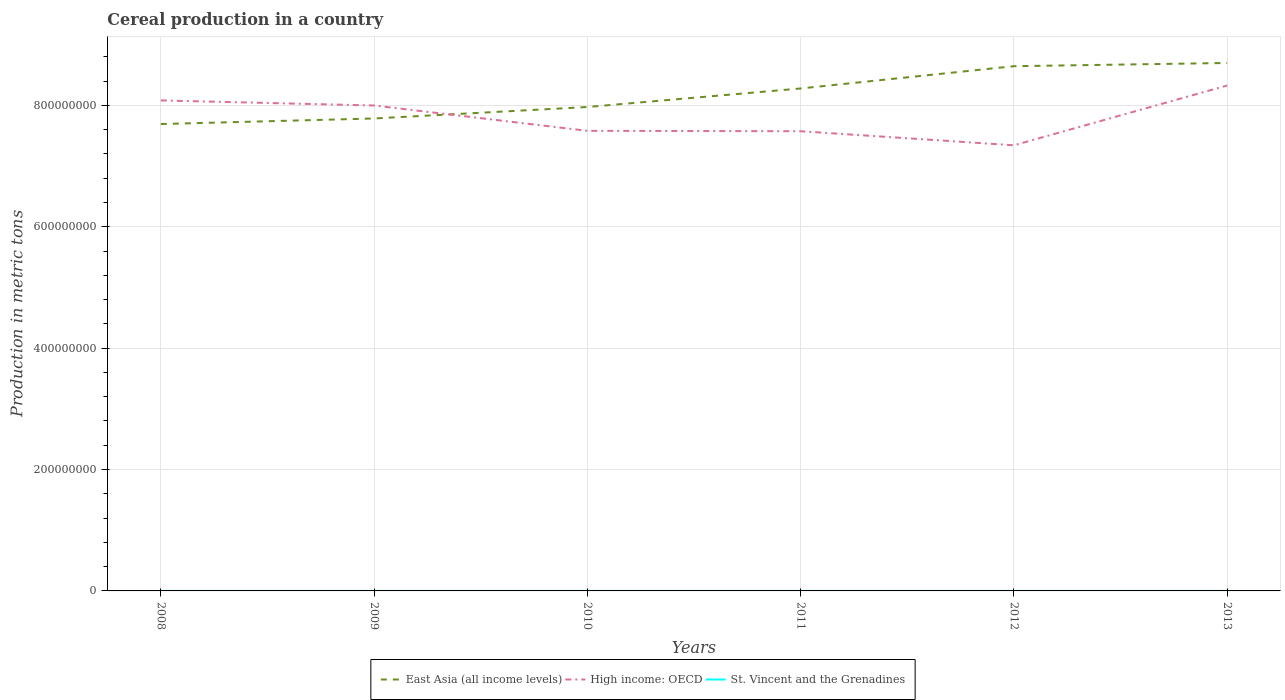Across all years, what is the maximum total cereal production in St. Vincent and the Grenadines?
Provide a succinct answer. 582. In which year was the total cereal production in High income: OECD maximum?
Make the answer very short. 2012. What is the total total cereal production in East Asia (all income levels) in the graph?
Your response must be concise. -9.53e+07. What is the difference between the highest and the second highest total cereal production in High income: OECD?
Ensure brevity in your answer.  9.85e+07. What is the difference between the highest and the lowest total cereal production in St. Vincent and the Grenadines?
Provide a succinct answer. 2. How many years are there in the graph?
Keep it short and to the point. 6. Where does the legend appear in the graph?
Keep it short and to the point. Bottom center. What is the title of the graph?
Provide a succinct answer. Cereal production in a country. What is the label or title of the X-axis?
Offer a very short reply. Years. What is the label or title of the Y-axis?
Your answer should be compact. Production in metric tons. What is the Production in metric tons in East Asia (all income levels) in 2008?
Your answer should be compact. 7.69e+08. What is the Production in metric tons of High income: OECD in 2008?
Make the answer very short. 8.08e+08. What is the Production in metric tons of St. Vincent and the Grenadines in 2008?
Your answer should be very brief. 700. What is the Production in metric tons in East Asia (all income levels) in 2009?
Your answer should be compact. 7.78e+08. What is the Production in metric tons in High income: OECD in 2009?
Ensure brevity in your answer.  8.00e+08. What is the Production in metric tons in St. Vincent and the Grenadines in 2009?
Your response must be concise. 670. What is the Production in metric tons in East Asia (all income levels) in 2010?
Provide a short and direct response. 7.97e+08. What is the Production in metric tons in High income: OECD in 2010?
Provide a succinct answer. 7.58e+08. What is the Production in metric tons in St. Vincent and the Grenadines in 2010?
Keep it short and to the point. 582. What is the Production in metric tons of East Asia (all income levels) in 2011?
Your response must be concise. 8.28e+08. What is the Production in metric tons in High income: OECD in 2011?
Make the answer very short. 7.57e+08. What is the Production in metric tons in St. Vincent and the Grenadines in 2011?
Give a very brief answer. 691. What is the Production in metric tons in East Asia (all income levels) in 2012?
Your answer should be very brief. 8.64e+08. What is the Production in metric tons of High income: OECD in 2012?
Your answer should be compact. 7.34e+08. What is the Production in metric tons in St. Vincent and the Grenadines in 2012?
Give a very brief answer. 854. What is the Production in metric tons in East Asia (all income levels) in 2013?
Provide a short and direct response. 8.70e+08. What is the Production in metric tons in High income: OECD in 2013?
Provide a short and direct response. 8.33e+08. What is the Production in metric tons of St. Vincent and the Grenadines in 2013?
Keep it short and to the point. 870. Across all years, what is the maximum Production in metric tons in East Asia (all income levels)?
Provide a short and direct response. 8.70e+08. Across all years, what is the maximum Production in metric tons of High income: OECD?
Offer a very short reply. 8.33e+08. Across all years, what is the maximum Production in metric tons in St. Vincent and the Grenadines?
Your answer should be very brief. 870. Across all years, what is the minimum Production in metric tons in East Asia (all income levels)?
Offer a terse response. 7.69e+08. Across all years, what is the minimum Production in metric tons of High income: OECD?
Give a very brief answer. 7.34e+08. Across all years, what is the minimum Production in metric tons of St. Vincent and the Grenadines?
Offer a terse response. 582. What is the total Production in metric tons in East Asia (all income levels) in the graph?
Provide a succinct answer. 4.91e+09. What is the total Production in metric tons of High income: OECD in the graph?
Make the answer very short. 4.69e+09. What is the total Production in metric tons in St. Vincent and the Grenadines in the graph?
Offer a very short reply. 4367. What is the difference between the Production in metric tons of East Asia (all income levels) in 2008 and that in 2009?
Your answer should be very brief. -9.17e+06. What is the difference between the Production in metric tons in High income: OECD in 2008 and that in 2009?
Make the answer very short. 8.34e+06. What is the difference between the Production in metric tons in East Asia (all income levels) in 2008 and that in 2010?
Provide a short and direct response. -2.81e+07. What is the difference between the Production in metric tons of High income: OECD in 2008 and that in 2010?
Offer a very short reply. 5.01e+07. What is the difference between the Production in metric tons in St. Vincent and the Grenadines in 2008 and that in 2010?
Provide a short and direct response. 118. What is the difference between the Production in metric tons in East Asia (all income levels) in 2008 and that in 2011?
Offer a very short reply. -5.86e+07. What is the difference between the Production in metric tons in High income: OECD in 2008 and that in 2011?
Give a very brief answer. 5.07e+07. What is the difference between the Production in metric tons of St. Vincent and the Grenadines in 2008 and that in 2011?
Offer a very short reply. 9. What is the difference between the Production in metric tons of East Asia (all income levels) in 2008 and that in 2012?
Offer a very short reply. -9.53e+07. What is the difference between the Production in metric tons of High income: OECD in 2008 and that in 2012?
Make the answer very short. 7.39e+07. What is the difference between the Production in metric tons of St. Vincent and the Grenadines in 2008 and that in 2012?
Give a very brief answer. -154. What is the difference between the Production in metric tons of East Asia (all income levels) in 2008 and that in 2013?
Ensure brevity in your answer.  -1.01e+08. What is the difference between the Production in metric tons of High income: OECD in 2008 and that in 2013?
Your response must be concise. -2.46e+07. What is the difference between the Production in metric tons in St. Vincent and the Grenadines in 2008 and that in 2013?
Offer a terse response. -170. What is the difference between the Production in metric tons in East Asia (all income levels) in 2009 and that in 2010?
Offer a very short reply. -1.89e+07. What is the difference between the Production in metric tons in High income: OECD in 2009 and that in 2010?
Your answer should be very brief. 4.17e+07. What is the difference between the Production in metric tons in St. Vincent and the Grenadines in 2009 and that in 2010?
Provide a succinct answer. 88. What is the difference between the Production in metric tons in East Asia (all income levels) in 2009 and that in 2011?
Your answer should be compact. -4.94e+07. What is the difference between the Production in metric tons in High income: OECD in 2009 and that in 2011?
Give a very brief answer. 4.24e+07. What is the difference between the Production in metric tons in St. Vincent and the Grenadines in 2009 and that in 2011?
Your response must be concise. -21. What is the difference between the Production in metric tons of East Asia (all income levels) in 2009 and that in 2012?
Your response must be concise. -8.61e+07. What is the difference between the Production in metric tons in High income: OECD in 2009 and that in 2012?
Your answer should be compact. 6.56e+07. What is the difference between the Production in metric tons of St. Vincent and the Grenadines in 2009 and that in 2012?
Offer a very short reply. -184. What is the difference between the Production in metric tons in East Asia (all income levels) in 2009 and that in 2013?
Your answer should be very brief. -9.14e+07. What is the difference between the Production in metric tons in High income: OECD in 2009 and that in 2013?
Give a very brief answer. -3.29e+07. What is the difference between the Production in metric tons of St. Vincent and the Grenadines in 2009 and that in 2013?
Provide a short and direct response. -200. What is the difference between the Production in metric tons in East Asia (all income levels) in 2010 and that in 2011?
Your answer should be very brief. -3.06e+07. What is the difference between the Production in metric tons of High income: OECD in 2010 and that in 2011?
Keep it short and to the point. 6.61e+05. What is the difference between the Production in metric tons in St. Vincent and the Grenadines in 2010 and that in 2011?
Your response must be concise. -109. What is the difference between the Production in metric tons of East Asia (all income levels) in 2010 and that in 2012?
Your response must be concise. -6.72e+07. What is the difference between the Production in metric tons in High income: OECD in 2010 and that in 2012?
Offer a terse response. 2.38e+07. What is the difference between the Production in metric tons in St. Vincent and the Grenadines in 2010 and that in 2012?
Provide a succinct answer. -272. What is the difference between the Production in metric tons of East Asia (all income levels) in 2010 and that in 2013?
Your answer should be compact. -7.26e+07. What is the difference between the Production in metric tons in High income: OECD in 2010 and that in 2013?
Offer a terse response. -7.47e+07. What is the difference between the Production in metric tons of St. Vincent and the Grenadines in 2010 and that in 2013?
Provide a short and direct response. -288. What is the difference between the Production in metric tons in East Asia (all income levels) in 2011 and that in 2012?
Provide a short and direct response. -3.67e+07. What is the difference between the Production in metric tons of High income: OECD in 2011 and that in 2012?
Offer a very short reply. 2.32e+07. What is the difference between the Production in metric tons of St. Vincent and the Grenadines in 2011 and that in 2012?
Make the answer very short. -163. What is the difference between the Production in metric tons in East Asia (all income levels) in 2011 and that in 2013?
Your answer should be very brief. -4.20e+07. What is the difference between the Production in metric tons in High income: OECD in 2011 and that in 2013?
Give a very brief answer. -7.53e+07. What is the difference between the Production in metric tons in St. Vincent and the Grenadines in 2011 and that in 2013?
Provide a short and direct response. -179. What is the difference between the Production in metric tons of East Asia (all income levels) in 2012 and that in 2013?
Provide a succinct answer. -5.31e+06. What is the difference between the Production in metric tons of High income: OECD in 2012 and that in 2013?
Your answer should be very brief. -9.85e+07. What is the difference between the Production in metric tons of East Asia (all income levels) in 2008 and the Production in metric tons of High income: OECD in 2009?
Provide a succinct answer. -3.06e+07. What is the difference between the Production in metric tons in East Asia (all income levels) in 2008 and the Production in metric tons in St. Vincent and the Grenadines in 2009?
Make the answer very short. 7.69e+08. What is the difference between the Production in metric tons in High income: OECD in 2008 and the Production in metric tons in St. Vincent and the Grenadines in 2009?
Offer a very short reply. 8.08e+08. What is the difference between the Production in metric tons of East Asia (all income levels) in 2008 and the Production in metric tons of High income: OECD in 2010?
Your answer should be compact. 1.12e+07. What is the difference between the Production in metric tons of East Asia (all income levels) in 2008 and the Production in metric tons of St. Vincent and the Grenadines in 2010?
Your answer should be compact. 7.69e+08. What is the difference between the Production in metric tons of High income: OECD in 2008 and the Production in metric tons of St. Vincent and the Grenadines in 2010?
Keep it short and to the point. 8.08e+08. What is the difference between the Production in metric tons of East Asia (all income levels) in 2008 and the Production in metric tons of High income: OECD in 2011?
Offer a very short reply. 1.18e+07. What is the difference between the Production in metric tons of East Asia (all income levels) in 2008 and the Production in metric tons of St. Vincent and the Grenadines in 2011?
Keep it short and to the point. 7.69e+08. What is the difference between the Production in metric tons of High income: OECD in 2008 and the Production in metric tons of St. Vincent and the Grenadines in 2011?
Your answer should be very brief. 8.08e+08. What is the difference between the Production in metric tons of East Asia (all income levels) in 2008 and the Production in metric tons of High income: OECD in 2012?
Provide a succinct answer. 3.50e+07. What is the difference between the Production in metric tons in East Asia (all income levels) in 2008 and the Production in metric tons in St. Vincent and the Grenadines in 2012?
Your response must be concise. 7.69e+08. What is the difference between the Production in metric tons in High income: OECD in 2008 and the Production in metric tons in St. Vincent and the Grenadines in 2012?
Offer a terse response. 8.08e+08. What is the difference between the Production in metric tons of East Asia (all income levels) in 2008 and the Production in metric tons of High income: OECD in 2013?
Give a very brief answer. -6.35e+07. What is the difference between the Production in metric tons in East Asia (all income levels) in 2008 and the Production in metric tons in St. Vincent and the Grenadines in 2013?
Provide a short and direct response. 7.69e+08. What is the difference between the Production in metric tons of High income: OECD in 2008 and the Production in metric tons of St. Vincent and the Grenadines in 2013?
Your response must be concise. 8.08e+08. What is the difference between the Production in metric tons in East Asia (all income levels) in 2009 and the Production in metric tons in High income: OECD in 2010?
Keep it short and to the point. 2.04e+07. What is the difference between the Production in metric tons in East Asia (all income levels) in 2009 and the Production in metric tons in St. Vincent and the Grenadines in 2010?
Offer a terse response. 7.78e+08. What is the difference between the Production in metric tons of High income: OECD in 2009 and the Production in metric tons of St. Vincent and the Grenadines in 2010?
Make the answer very short. 8.00e+08. What is the difference between the Production in metric tons of East Asia (all income levels) in 2009 and the Production in metric tons of High income: OECD in 2011?
Your answer should be very brief. 2.10e+07. What is the difference between the Production in metric tons of East Asia (all income levels) in 2009 and the Production in metric tons of St. Vincent and the Grenadines in 2011?
Make the answer very short. 7.78e+08. What is the difference between the Production in metric tons in High income: OECD in 2009 and the Production in metric tons in St. Vincent and the Grenadines in 2011?
Provide a succinct answer. 8.00e+08. What is the difference between the Production in metric tons in East Asia (all income levels) in 2009 and the Production in metric tons in High income: OECD in 2012?
Provide a succinct answer. 4.42e+07. What is the difference between the Production in metric tons of East Asia (all income levels) in 2009 and the Production in metric tons of St. Vincent and the Grenadines in 2012?
Give a very brief answer. 7.78e+08. What is the difference between the Production in metric tons of High income: OECD in 2009 and the Production in metric tons of St. Vincent and the Grenadines in 2012?
Offer a terse response. 8.00e+08. What is the difference between the Production in metric tons in East Asia (all income levels) in 2009 and the Production in metric tons in High income: OECD in 2013?
Keep it short and to the point. -5.43e+07. What is the difference between the Production in metric tons of East Asia (all income levels) in 2009 and the Production in metric tons of St. Vincent and the Grenadines in 2013?
Make the answer very short. 7.78e+08. What is the difference between the Production in metric tons of High income: OECD in 2009 and the Production in metric tons of St. Vincent and the Grenadines in 2013?
Your answer should be very brief. 8.00e+08. What is the difference between the Production in metric tons of East Asia (all income levels) in 2010 and the Production in metric tons of High income: OECD in 2011?
Your response must be concise. 3.99e+07. What is the difference between the Production in metric tons of East Asia (all income levels) in 2010 and the Production in metric tons of St. Vincent and the Grenadines in 2011?
Your response must be concise. 7.97e+08. What is the difference between the Production in metric tons of High income: OECD in 2010 and the Production in metric tons of St. Vincent and the Grenadines in 2011?
Offer a terse response. 7.58e+08. What is the difference between the Production in metric tons in East Asia (all income levels) in 2010 and the Production in metric tons in High income: OECD in 2012?
Provide a short and direct response. 6.30e+07. What is the difference between the Production in metric tons of East Asia (all income levels) in 2010 and the Production in metric tons of St. Vincent and the Grenadines in 2012?
Ensure brevity in your answer.  7.97e+08. What is the difference between the Production in metric tons in High income: OECD in 2010 and the Production in metric tons in St. Vincent and the Grenadines in 2012?
Ensure brevity in your answer.  7.58e+08. What is the difference between the Production in metric tons of East Asia (all income levels) in 2010 and the Production in metric tons of High income: OECD in 2013?
Give a very brief answer. -3.54e+07. What is the difference between the Production in metric tons in East Asia (all income levels) in 2010 and the Production in metric tons in St. Vincent and the Grenadines in 2013?
Your answer should be compact. 7.97e+08. What is the difference between the Production in metric tons in High income: OECD in 2010 and the Production in metric tons in St. Vincent and the Grenadines in 2013?
Ensure brevity in your answer.  7.58e+08. What is the difference between the Production in metric tons of East Asia (all income levels) in 2011 and the Production in metric tons of High income: OECD in 2012?
Ensure brevity in your answer.  9.36e+07. What is the difference between the Production in metric tons of East Asia (all income levels) in 2011 and the Production in metric tons of St. Vincent and the Grenadines in 2012?
Offer a terse response. 8.28e+08. What is the difference between the Production in metric tons of High income: OECD in 2011 and the Production in metric tons of St. Vincent and the Grenadines in 2012?
Offer a very short reply. 7.57e+08. What is the difference between the Production in metric tons of East Asia (all income levels) in 2011 and the Production in metric tons of High income: OECD in 2013?
Provide a succinct answer. -4.87e+06. What is the difference between the Production in metric tons in East Asia (all income levels) in 2011 and the Production in metric tons in St. Vincent and the Grenadines in 2013?
Your answer should be compact. 8.28e+08. What is the difference between the Production in metric tons of High income: OECD in 2011 and the Production in metric tons of St. Vincent and the Grenadines in 2013?
Provide a short and direct response. 7.57e+08. What is the difference between the Production in metric tons in East Asia (all income levels) in 2012 and the Production in metric tons in High income: OECD in 2013?
Your answer should be compact. 3.18e+07. What is the difference between the Production in metric tons in East Asia (all income levels) in 2012 and the Production in metric tons in St. Vincent and the Grenadines in 2013?
Ensure brevity in your answer.  8.64e+08. What is the difference between the Production in metric tons in High income: OECD in 2012 and the Production in metric tons in St. Vincent and the Grenadines in 2013?
Give a very brief answer. 7.34e+08. What is the average Production in metric tons of East Asia (all income levels) per year?
Keep it short and to the point. 8.18e+08. What is the average Production in metric tons of High income: OECD per year?
Offer a very short reply. 7.82e+08. What is the average Production in metric tons in St. Vincent and the Grenadines per year?
Ensure brevity in your answer.  727.83. In the year 2008, what is the difference between the Production in metric tons in East Asia (all income levels) and Production in metric tons in High income: OECD?
Offer a very short reply. -3.89e+07. In the year 2008, what is the difference between the Production in metric tons in East Asia (all income levels) and Production in metric tons in St. Vincent and the Grenadines?
Keep it short and to the point. 7.69e+08. In the year 2008, what is the difference between the Production in metric tons in High income: OECD and Production in metric tons in St. Vincent and the Grenadines?
Make the answer very short. 8.08e+08. In the year 2009, what is the difference between the Production in metric tons in East Asia (all income levels) and Production in metric tons in High income: OECD?
Provide a succinct answer. -2.14e+07. In the year 2009, what is the difference between the Production in metric tons in East Asia (all income levels) and Production in metric tons in St. Vincent and the Grenadines?
Make the answer very short. 7.78e+08. In the year 2009, what is the difference between the Production in metric tons of High income: OECD and Production in metric tons of St. Vincent and the Grenadines?
Keep it short and to the point. 8.00e+08. In the year 2010, what is the difference between the Production in metric tons in East Asia (all income levels) and Production in metric tons in High income: OECD?
Your answer should be compact. 3.92e+07. In the year 2010, what is the difference between the Production in metric tons in East Asia (all income levels) and Production in metric tons in St. Vincent and the Grenadines?
Your answer should be compact. 7.97e+08. In the year 2010, what is the difference between the Production in metric tons in High income: OECD and Production in metric tons in St. Vincent and the Grenadines?
Provide a short and direct response. 7.58e+08. In the year 2011, what is the difference between the Production in metric tons in East Asia (all income levels) and Production in metric tons in High income: OECD?
Your answer should be compact. 7.05e+07. In the year 2011, what is the difference between the Production in metric tons of East Asia (all income levels) and Production in metric tons of St. Vincent and the Grenadines?
Offer a very short reply. 8.28e+08. In the year 2011, what is the difference between the Production in metric tons of High income: OECD and Production in metric tons of St. Vincent and the Grenadines?
Offer a very short reply. 7.57e+08. In the year 2012, what is the difference between the Production in metric tons in East Asia (all income levels) and Production in metric tons in High income: OECD?
Your answer should be very brief. 1.30e+08. In the year 2012, what is the difference between the Production in metric tons of East Asia (all income levels) and Production in metric tons of St. Vincent and the Grenadines?
Keep it short and to the point. 8.64e+08. In the year 2012, what is the difference between the Production in metric tons of High income: OECD and Production in metric tons of St. Vincent and the Grenadines?
Your answer should be compact. 7.34e+08. In the year 2013, what is the difference between the Production in metric tons of East Asia (all income levels) and Production in metric tons of High income: OECD?
Make the answer very short. 3.71e+07. In the year 2013, what is the difference between the Production in metric tons in East Asia (all income levels) and Production in metric tons in St. Vincent and the Grenadines?
Your response must be concise. 8.70e+08. In the year 2013, what is the difference between the Production in metric tons in High income: OECD and Production in metric tons in St. Vincent and the Grenadines?
Keep it short and to the point. 8.33e+08. What is the ratio of the Production in metric tons in East Asia (all income levels) in 2008 to that in 2009?
Offer a very short reply. 0.99. What is the ratio of the Production in metric tons of High income: OECD in 2008 to that in 2009?
Provide a short and direct response. 1.01. What is the ratio of the Production in metric tons of St. Vincent and the Grenadines in 2008 to that in 2009?
Offer a very short reply. 1.04. What is the ratio of the Production in metric tons of East Asia (all income levels) in 2008 to that in 2010?
Your response must be concise. 0.96. What is the ratio of the Production in metric tons of High income: OECD in 2008 to that in 2010?
Provide a short and direct response. 1.07. What is the ratio of the Production in metric tons of St. Vincent and the Grenadines in 2008 to that in 2010?
Make the answer very short. 1.2. What is the ratio of the Production in metric tons in East Asia (all income levels) in 2008 to that in 2011?
Ensure brevity in your answer.  0.93. What is the ratio of the Production in metric tons of High income: OECD in 2008 to that in 2011?
Your answer should be compact. 1.07. What is the ratio of the Production in metric tons in East Asia (all income levels) in 2008 to that in 2012?
Provide a succinct answer. 0.89. What is the ratio of the Production in metric tons in High income: OECD in 2008 to that in 2012?
Your answer should be compact. 1.1. What is the ratio of the Production in metric tons in St. Vincent and the Grenadines in 2008 to that in 2012?
Provide a short and direct response. 0.82. What is the ratio of the Production in metric tons of East Asia (all income levels) in 2008 to that in 2013?
Provide a short and direct response. 0.88. What is the ratio of the Production in metric tons in High income: OECD in 2008 to that in 2013?
Your answer should be very brief. 0.97. What is the ratio of the Production in metric tons in St. Vincent and the Grenadines in 2008 to that in 2013?
Make the answer very short. 0.8. What is the ratio of the Production in metric tons in East Asia (all income levels) in 2009 to that in 2010?
Your answer should be compact. 0.98. What is the ratio of the Production in metric tons in High income: OECD in 2009 to that in 2010?
Give a very brief answer. 1.06. What is the ratio of the Production in metric tons of St. Vincent and the Grenadines in 2009 to that in 2010?
Keep it short and to the point. 1.15. What is the ratio of the Production in metric tons of East Asia (all income levels) in 2009 to that in 2011?
Ensure brevity in your answer.  0.94. What is the ratio of the Production in metric tons of High income: OECD in 2009 to that in 2011?
Provide a short and direct response. 1.06. What is the ratio of the Production in metric tons of St. Vincent and the Grenadines in 2009 to that in 2011?
Provide a short and direct response. 0.97. What is the ratio of the Production in metric tons in East Asia (all income levels) in 2009 to that in 2012?
Keep it short and to the point. 0.9. What is the ratio of the Production in metric tons of High income: OECD in 2009 to that in 2012?
Ensure brevity in your answer.  1.09. What is the ratio of the Production in metric tons of St. Vincent and the Grenadines in 2009 to that in 2012?
Give a very brief answer. 0.78. What is the ratio of the Production in metric tons in East Asia (all income levels) in 2009 to that in 2013?
Offer a terse response. 0.89. What is the ratio of the Production in metric tons in High income: OECD in 2009 to that in 2013?
Offer a very short reply. 0.96. What is the ratio of the Production in metric tons in St. Vincent and the Grenadines in 2009 to that in 2013?
Give a very brief answer. 0.77. What is the ratio of the Production in metric tons of East Asia (all income levels) in 2010 to that in 2011?
Provide a short and direct response. 0.96. What is the ratio of the Production in metric tons of St. Vincent and the Grenadines in 2010 to that in 2011?
Ensure brevity in your answer.  0.84. What is the ratio of the Production in metric tons in East Asia (all income levels) in 2010 to that in 2012?
Offer a terse response. 0.92. What is the ratio of the Production in metric tons in High income: OECD in 2010 to that in 2012?
Provide a short and direct response. 1.03. What is the ratio of the Production in metric tons in St. Vincent and the Grenadines in 2010 to that in 2012?
Keep it short and to the point. 0.68. What is the ratio of the Production in metric tons of East Asia (all income levels) in 2010 to that in 2013?
Your answer should be compact. 0.92. What is the ratio of the Production in metric tons of High income: OECD in 2010 to that in 2013?
Offer a very short reply. 0.91. What is the ratio of the Production in metric tons in St. Vincent and the Grenadines in 2010 to that in 2013?
Make the answer very short. 0.67. What is the ratio of the Production in metric tons of East Asia (all income levels) in 2011 to that in 2012?
Give a very brief answer. 0.96. What is the ratio of the Production in metric tons of High income: OECD in 2011 to that in 2012?
Your answer should be compact. 1.03. What is the ratio of the Production in metric tons in St. Vincent and the Grenadines in 2011 to that in 2012?
Give a very brief answer. 0.81. What is the ratio of the Production in metric tons in East Asia (all income levels) in 2011 to that in 2013?
Offer a very short reply. 0.95. What is the ratio of the Production in metric tons of High income: OECD in 2011 to that in 2013?
Offer a terse response. 0.91. What is the ratio of the Production in metric tons in St. Vincent and the Grenadines in 2011 to that in 2013?
Offer a very short reply. 0.79. What is the ratio of the Production in metric tons of High income: OECD in 2012 to that in 2013?
Keep it short and to the point. 0.88. What is the ratio of the Production in metric tons of St. Vincent and the Grenadines in 2012 to that in 2013?
Give a very brief answer. 0.98. What is the difference between the highest and the second highest Production in metric tons in East Asia (all income levels)?
Offer a terse response. 5.31e+06. What is the difference between the highest and the second highest Production in metric tons of High income: OECD?
Offer a very short reply. 2.46e+07. What is the difference between the highest and the second highest Production in metric tons of St. Vincent and the Grenadines?
Provide a short and direct response. 16. What is the difference between the highest and the lowest Production in metric tons in East Asia (all income levels)?
Give a very brief answer. 1.01e+08. What is the difference between the highest and the lowest Production in metric tons in High income: OECD?
Give a very brief answer. 9.85e+07. What is the difference between the highest and the lowest Production in metric tons of St. Vincent and the Grenadines?
Make the answer very short. 288. 